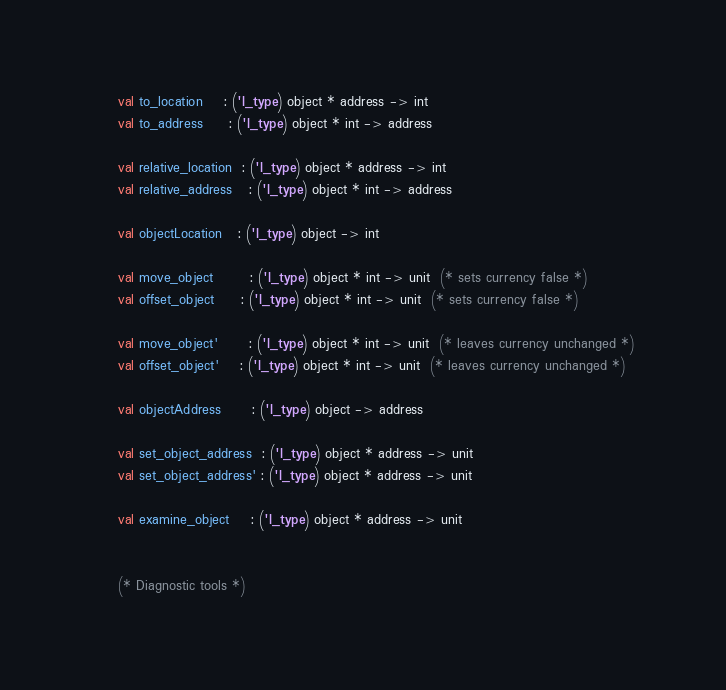Convert code to text. <code><loc_0><loc_0><loc_500><loc_500><_SML_>
     val to_location    : ('l_type) object * address -> int
     val to_address     : ('l_type) object * int -> address

     val relative_location  : ('l_type) object * address -> int
     val relative_address   : ('l_type) object * int -> address
     
     val objectLocation   : ('l_type) object -> int

     val move_object       : ('l_type) object * int -> unit  (* sets currency false *)
     val offset_object     : ('l_type) object * int -> unit  (* sets currency false *)

     val move_object'      : ('l_type) object * int -> unit  (* leaves currency unchanged *)
     val offset_object'    : ('l_type) object * int -> unit  (* leaves currency unchanged *)

     val objectAddress      : ('l_type) object -> address

     val set_object_address  : ('l_type) object * address -> unit
     val set_object_address' : ('l_type) object * address -> unit
  
     val examine_object    : ('l_type) object * address -> unit


     (* Diagnostic tools *)
</code> 